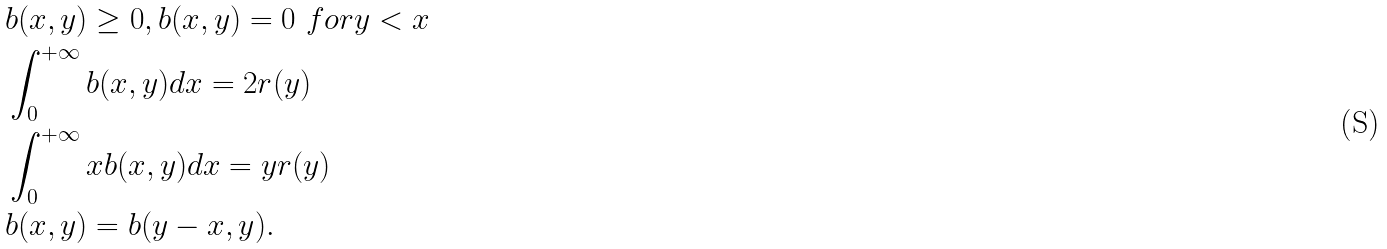<formula> <loc_0><loc_0><loc_500><loc_500>& b ( x , y ) \geq 0 , b ( x , y ) = 0 \ f o r y < x \\ & \int _ { 0 } ^ { + \infty } b ( x , y ) d x = 2 r ( y ) \\ & \int _ { 0 } ^ { + \infty } x b ( x , y ) d x = y r ( y ) \\ & b ( x , y ) = b ( y - x , y ) .</formula> 